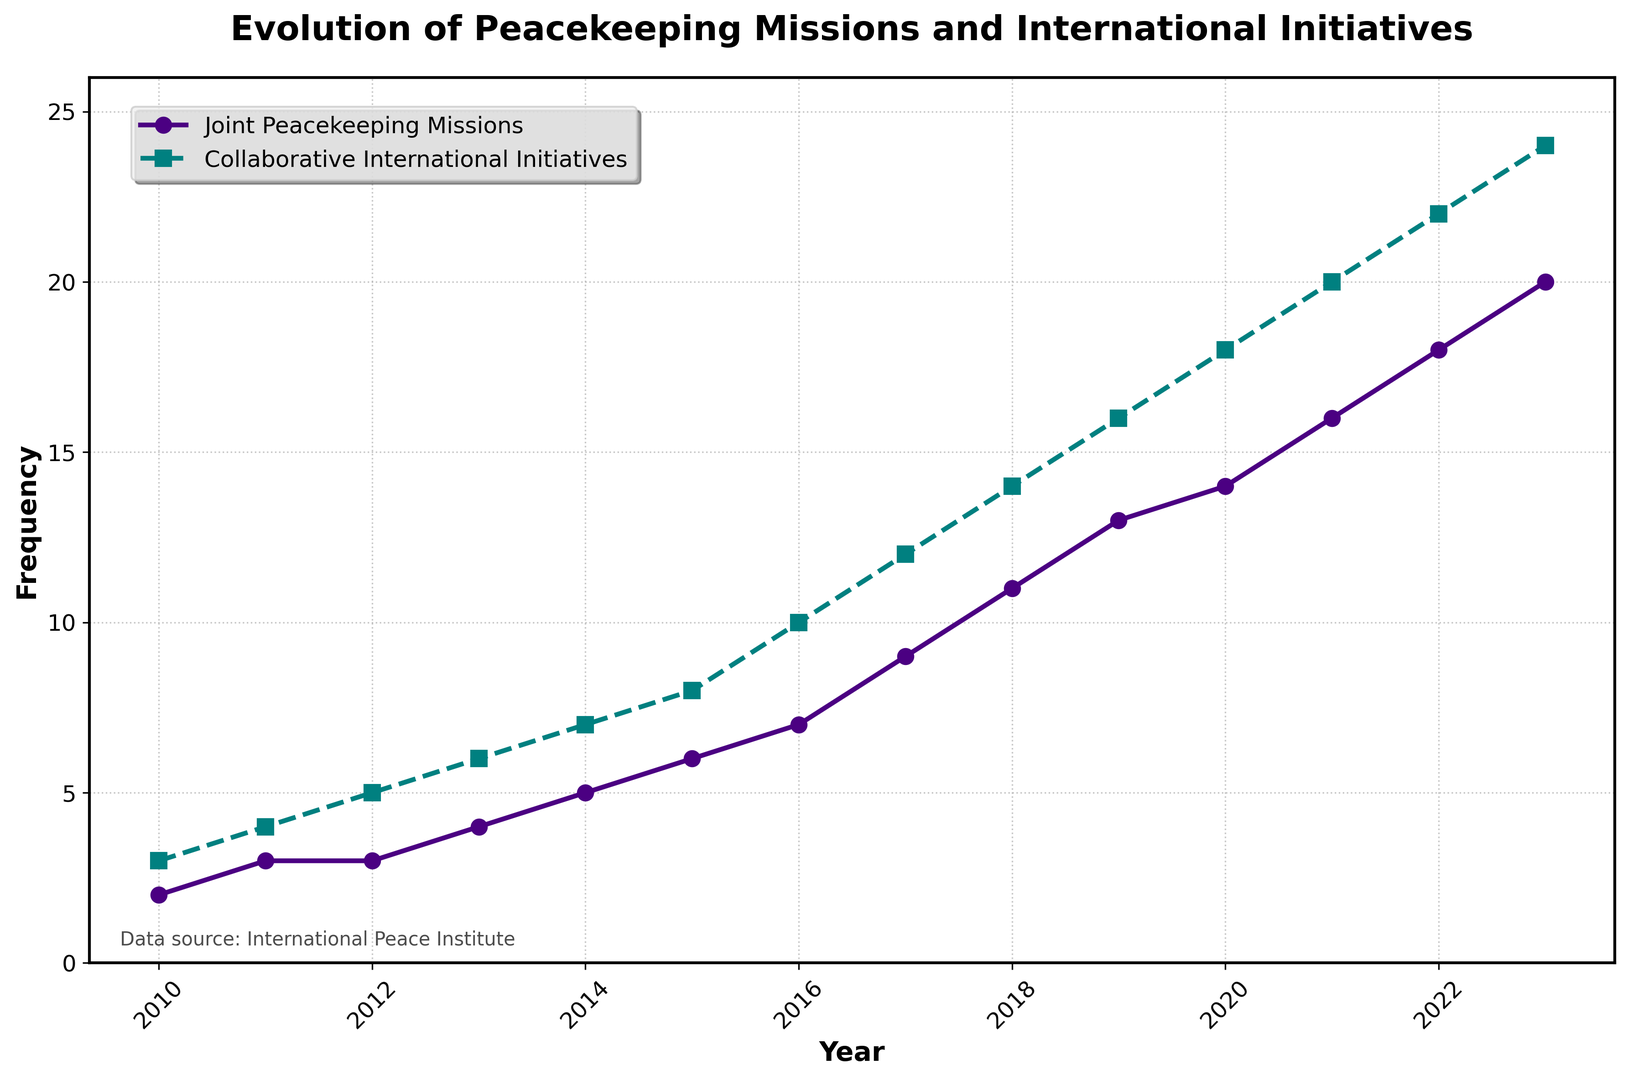What year had the greatest increase in joint peacekeeping missions compared to the previous year? To find the year with the greatest increase, we need to calculate the difference in the number of joint peacekeeping missions for each year compared to the previous year. The largest increase occurred between 2016 and 2017, where the number of joint peacekeeping missions increased from 7 to 9 (+2).
Answer: 2017 When were the number of joint peacekeeping missions and collaborative international initiatives equal? By examining the figure, we can see that the number of joint peacekeeping missions and collaborative international initiatives are never exactly equal at any point from 2010 to 2023.
Answer: Never What is the average number of joint peacekeeping missions over the entire period? Add the number of joint peacekeeping missions from all years and divide by the number of years: (2 + 3 + 3 + 4 + 5 + 6 + 7 + 9 + 11 + 13 + 14 + 16 + 18 + 20) / 14 = 8.57
Answer: 8.57 How many more collaborative international initiatives than joint peacekeeping missions were there in 2020? In 2020, there were 18 collaborative international initiatives and 14 joint peacekeeping missions. The difference is 18 - 14 = 4.
Answer: 4 During which year did the number of collaborative international initiatives surpass 10? Looking at the figure, we see that in 2016, there were 10 collaborative international initiatives. They surpassed 10 in 2017 when they reached 12.
Answer: 2017 Which color is used to represent the joint peacekeeping missions? The color used to represent joint peacekeeping missions in the figure is a shade of purple.
Answer: Purple How much increase in collaborative international initiatives occurred between 2013 and 2023? Calculate the difference between the number of initiatives in 2013 and 2023: 24 (2023) - 6 (2013) = 18.
Answer: 18 What's the difference between the median number of joint peacekeeping missions and collaborative international initiatives over the period? Find the median values by organizing the data. For joint peacekeeping missions: the median is 7 (middle value). For collaborative international initiatives: the median is 14 (middle value). The difference is 14 - 7 = 7.
Answer: 7 Which series has a more significant upward trend throughout the years? Both series show an upward trend, but collaborative international initiatives start from a higher base and increase to a higher peak. Visually, the green line representing collaborative international initiatives displays a steeper and more significant upward trend.
Answer: Collaborative international initiatives 